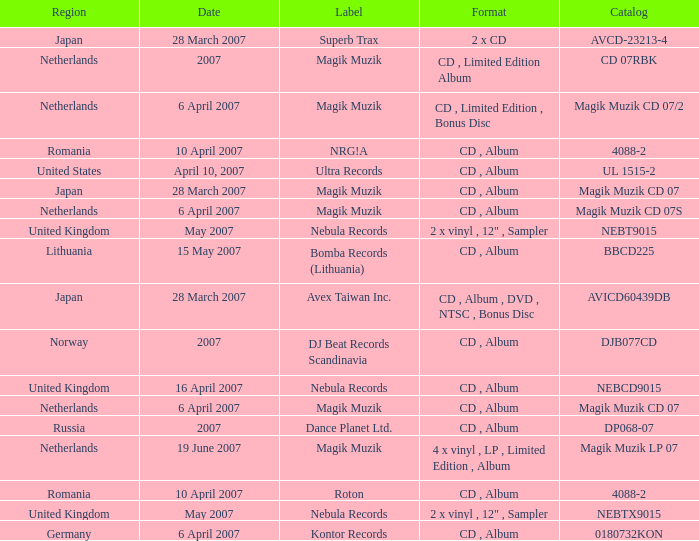Which label released the catalog Magik Muzik CD 07 on 28 March 2007? Magik Muzik. 